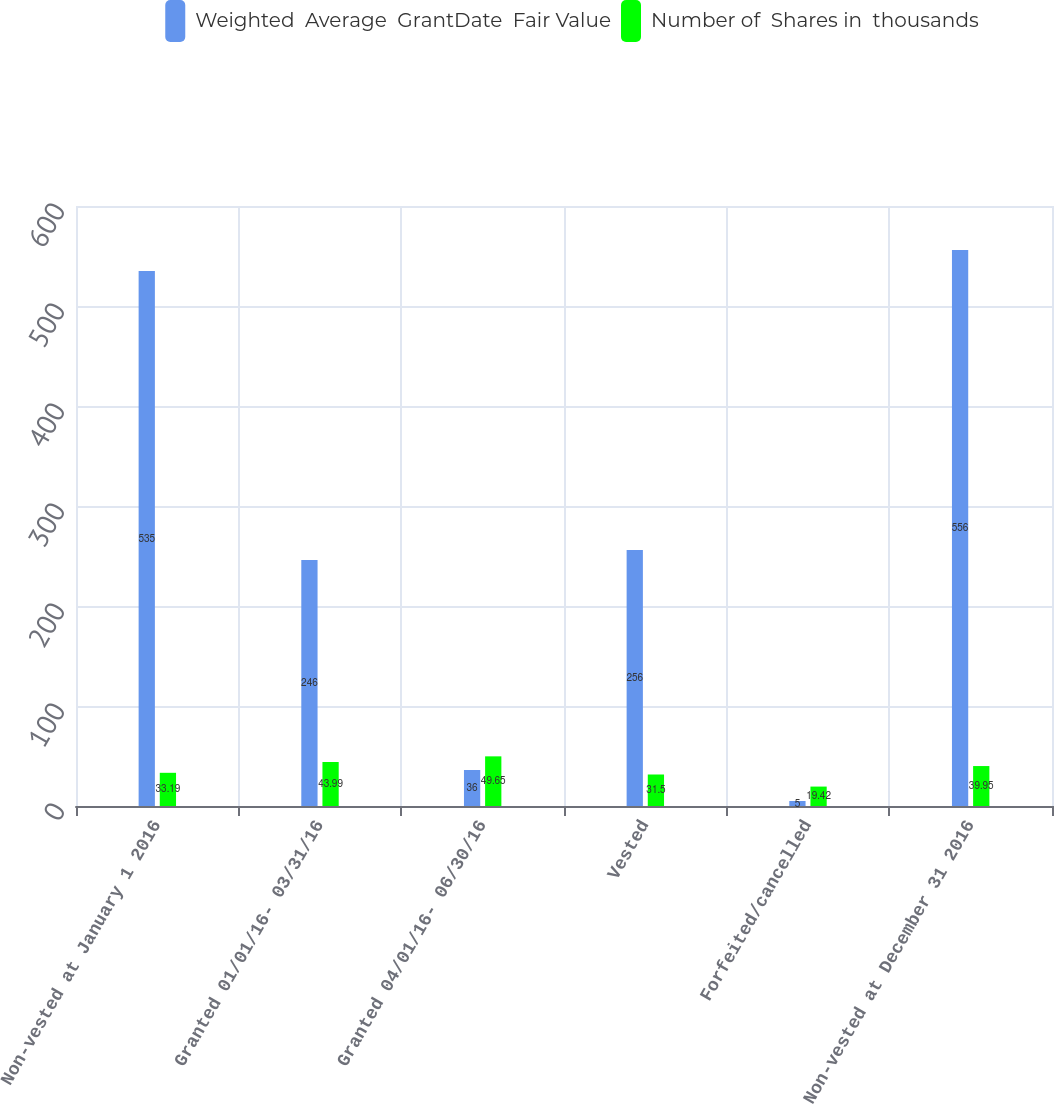Convert chart to OTSL. <chart><loc_0><loc_0><loc_500><loc_500><stacked_bar_chart><ecel><fcel>Non-vested at January 1 2016<fcel>Granted 01/01/16- 03/31/16<fcel>Granted 04/01/16- 06/30/16<fcel>Vested<fcel>Forfeited/cancelled<fcel>Non-vested at December 31 2016<nl><fcel>Weighted  Average  GrantDate  Fair Value<fcel>535<fcel>246<fcel>36<fcel>256<fcel>5<fcel>556<nl><fcel>Number of  Shares in  thousands<fcel>33.19<fcel>43.99<fcel>49.65<fcel>31.5<fcel>19.42<fcel>39.95<nl></chart> 